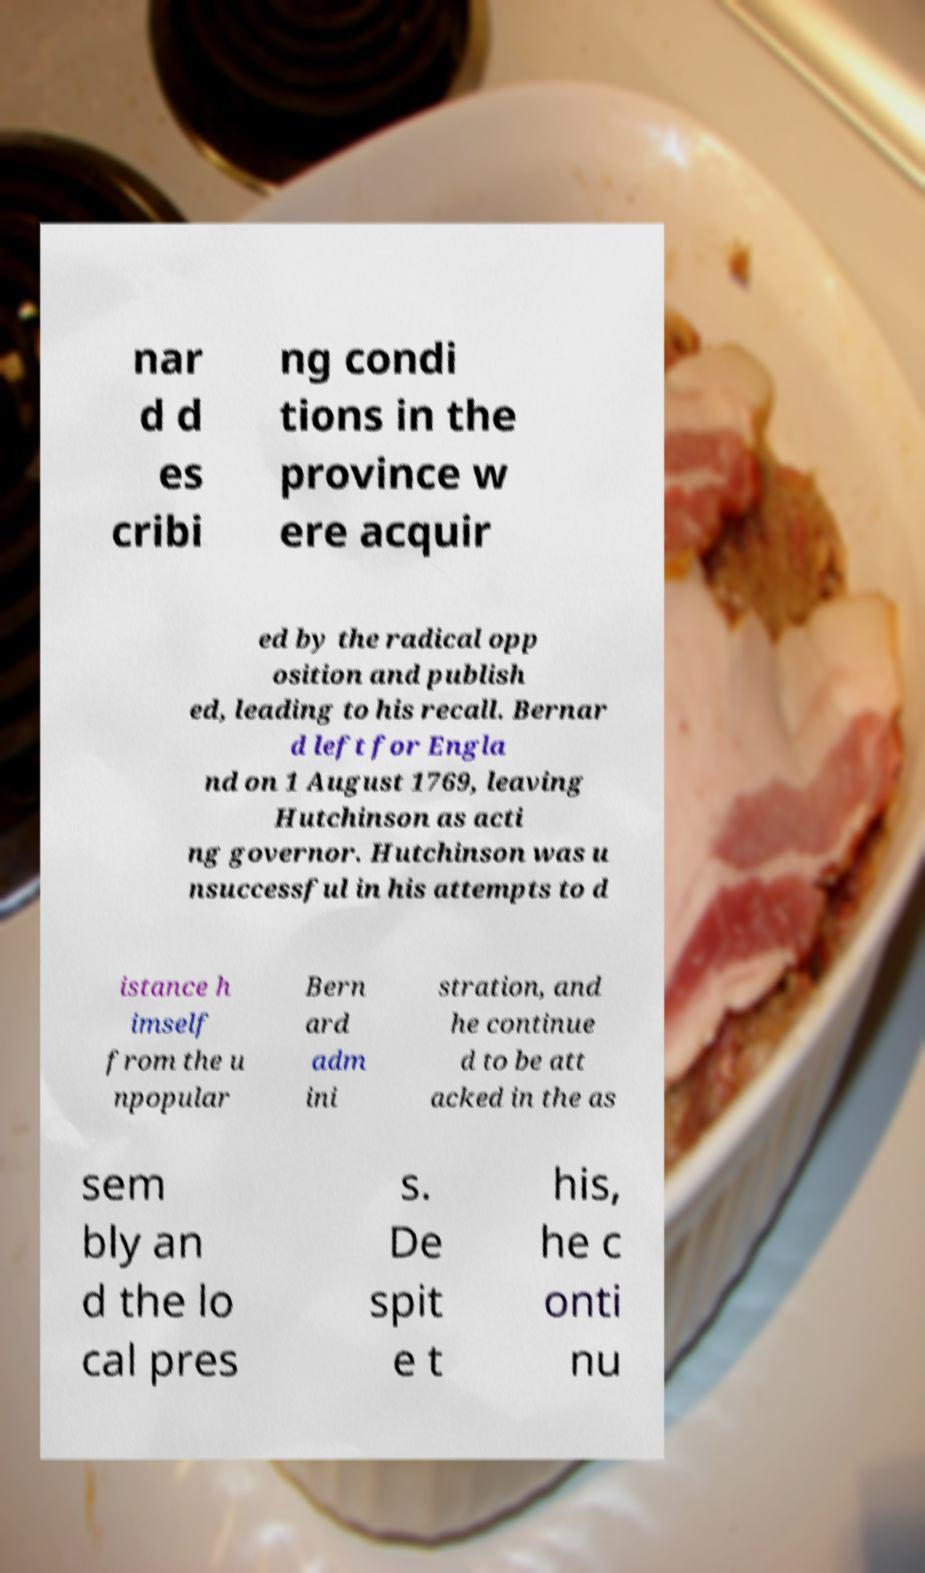Please identify and transcribe the text found in this image. nar d d es cribi ng condi tions in the province w ere acquir ed by the radical opp osition and publish ed, leading to his recall. Bernar d left for Engla nd on 1 August 1769, leaving Hutchinson as acti ng governor. Hutchinson was u nsuccessful in his attempts to d istance h imself from the u npopular Bern ard adm ini stration, and he continue d to be att acked in the as sem bly an d the lo cal pres s. De spit e t his, he c onti nu 